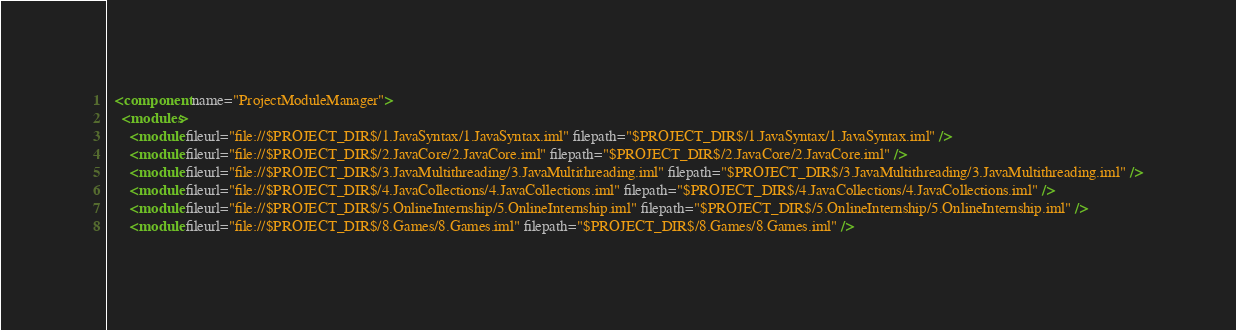<code> <loc_0><loc_0><loc_500><loc_500><_XML_>  <component name="ProjectModuleManager">
    <modules>
      <module fileurl="file://$PROJECT_DIR$/1.JavaSyntax/1.JavaSyntax.iml" filepath="$PROJECT_DIR$/1.JavaSyntax/1.JavaSyntax.iml" />
      <module fileurl="file://$PROJECT_DIR$/2.JavaCore/2.JavaCore.iml" filepath="$PROJECT_DIR$/2.JavaCore/2.JavaCore.iml" />
      <module fileurl="file://$PROJECT_DIR$/3.JavaMultithreading/3.JavaMultithreading.iml" filepath="$PROJECT_DIR$/3.JavaMultithreading/3.JavaMultithreading.iml" />
      <module fileurl="file://$PROJECT_DIR$/4.JavaCollections/4.JavaCollections.iml" filepath="$PROJECT_DIR$/4.JavaCollections/4.JavaCollections.iml" />
      <module fileurl="file://$PROJECT_DIR$/5.OnlineInternship/5.OnlineInternship.iml" filepath="$PROJECT_DIR$/5.OnlineInternship/5.OnlineInternship.iml" />
      <module fileurl="file://$PROJECT_DIR$/8.Games/8.Games.iml" filepath="$PROJECT_DIR$/8.Games/8.Games.iml" /></code> 